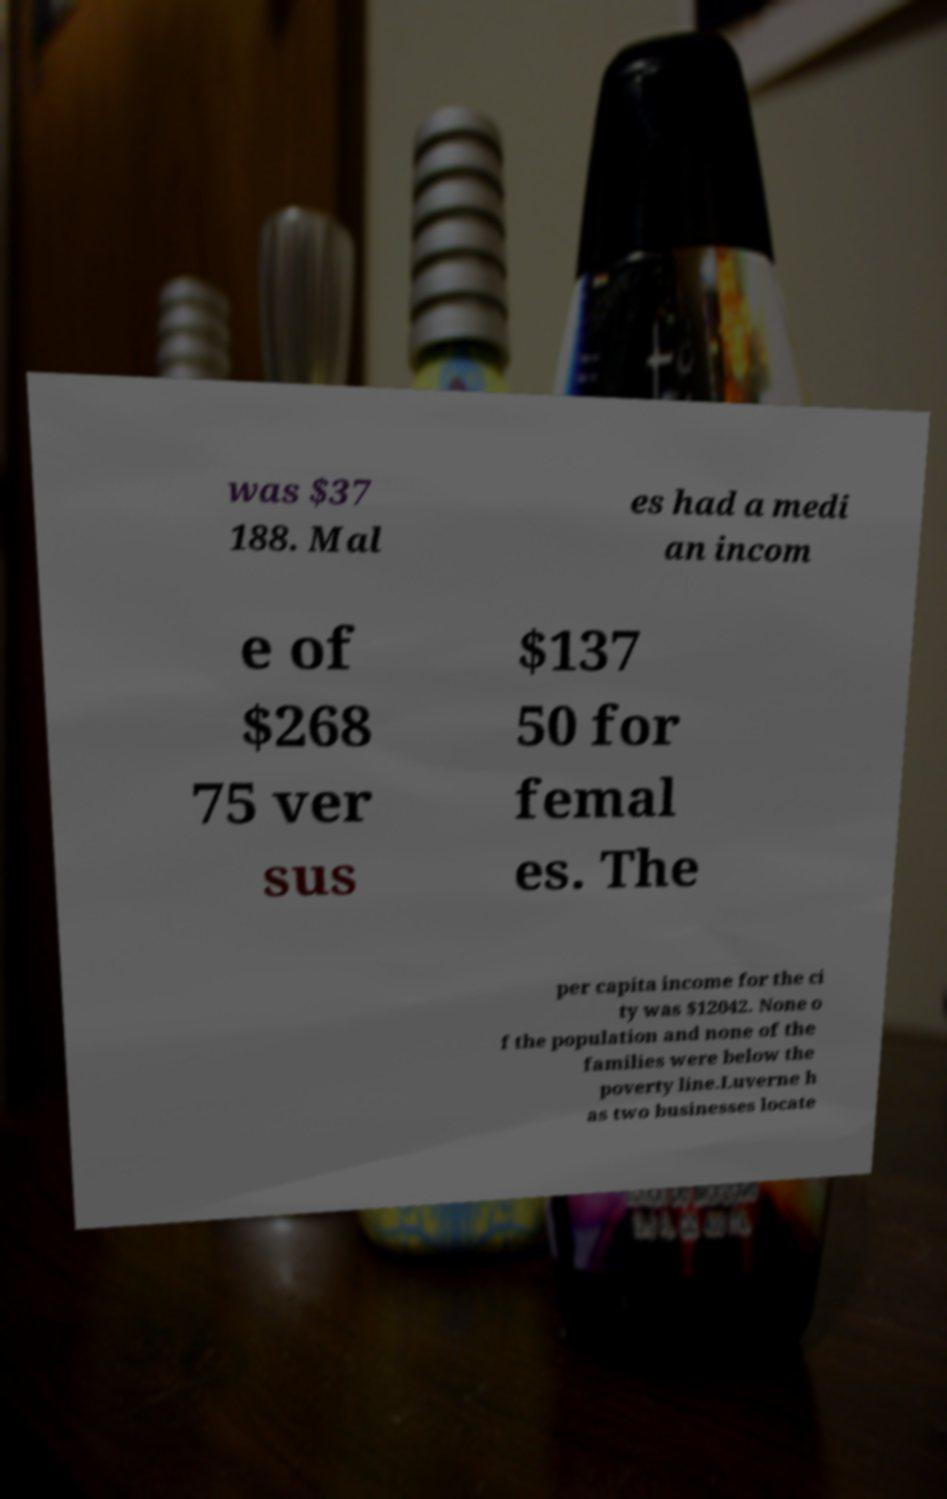Please identify and transcribe the text found in this image. was $37 188. Mal es had a medi an incom e of $268 75 ver sus $137 50 for femal es. The per capita income for the ci ty was $12042. None o f the population and none of the families were below the poverty line.Luverne h as two businesses locate 